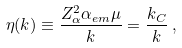Convert formula to latex. <formula><loc_0><loc_0><loc_500><loc_500>\eta ( k ) \equiv \frac { Z _ { \alpha } ^ { 2 } \alpha _ { e m } \mu } { k } = \frac { k _ { C } } { k } \, ,</formula> 